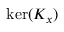Convert formula to latex. <formula><loc_0><loc_0><loc_500><loc_500>\ker ( K _ { x } )</formula> 